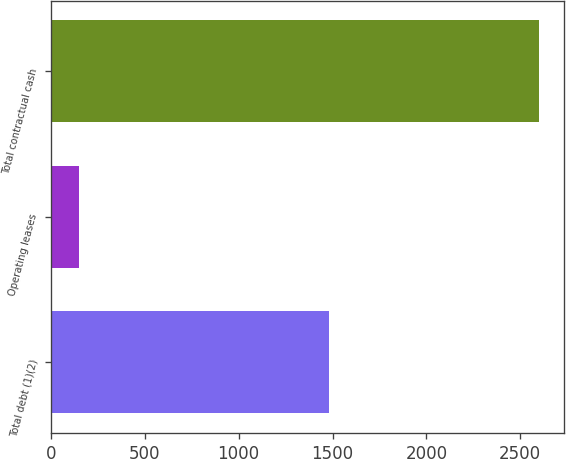Convert chart to OTSL. <chart><loc_0><loc_0><loc_500><loc_500><bar_chart><fcel>Total debt (1)(2)<fcel>Operating leases<fcel>Total contractual cash<nl><fcel>1481.2<fcel>151<fcel>2601.2<nl></chart> 